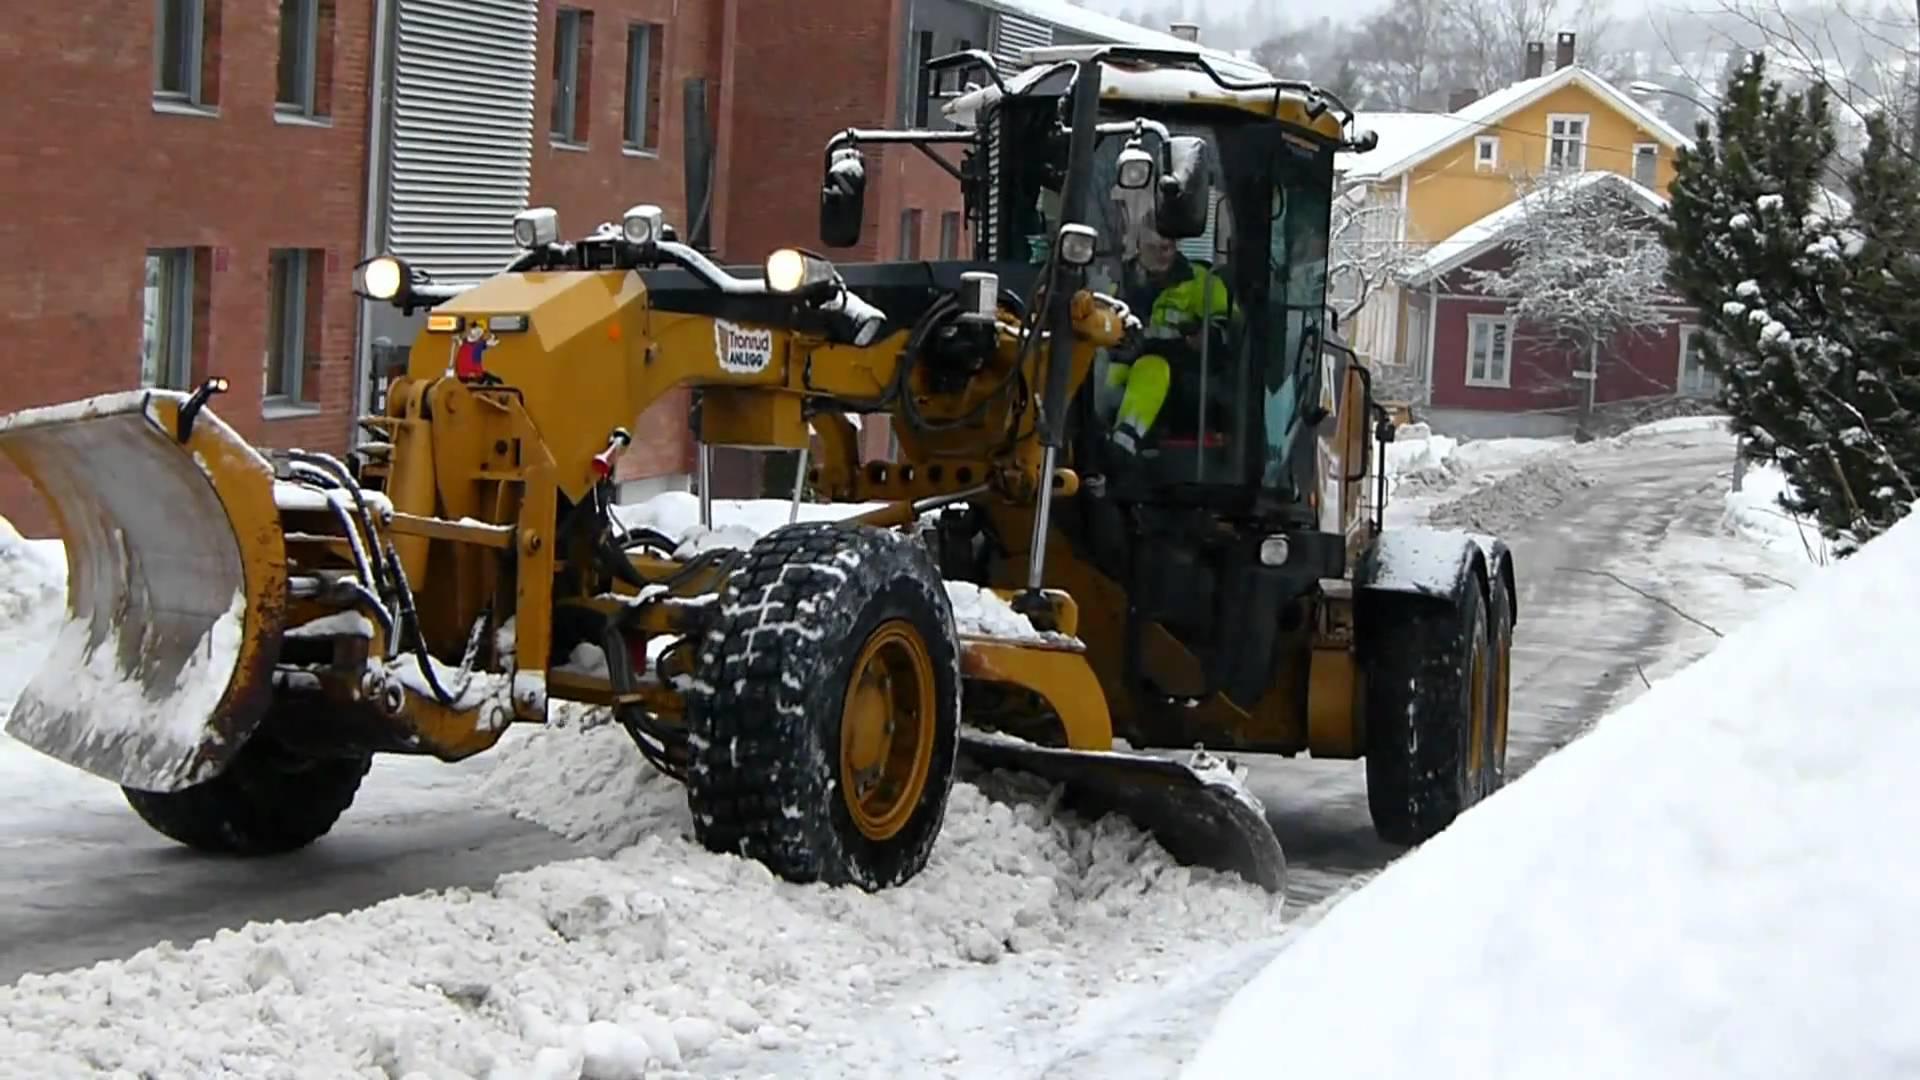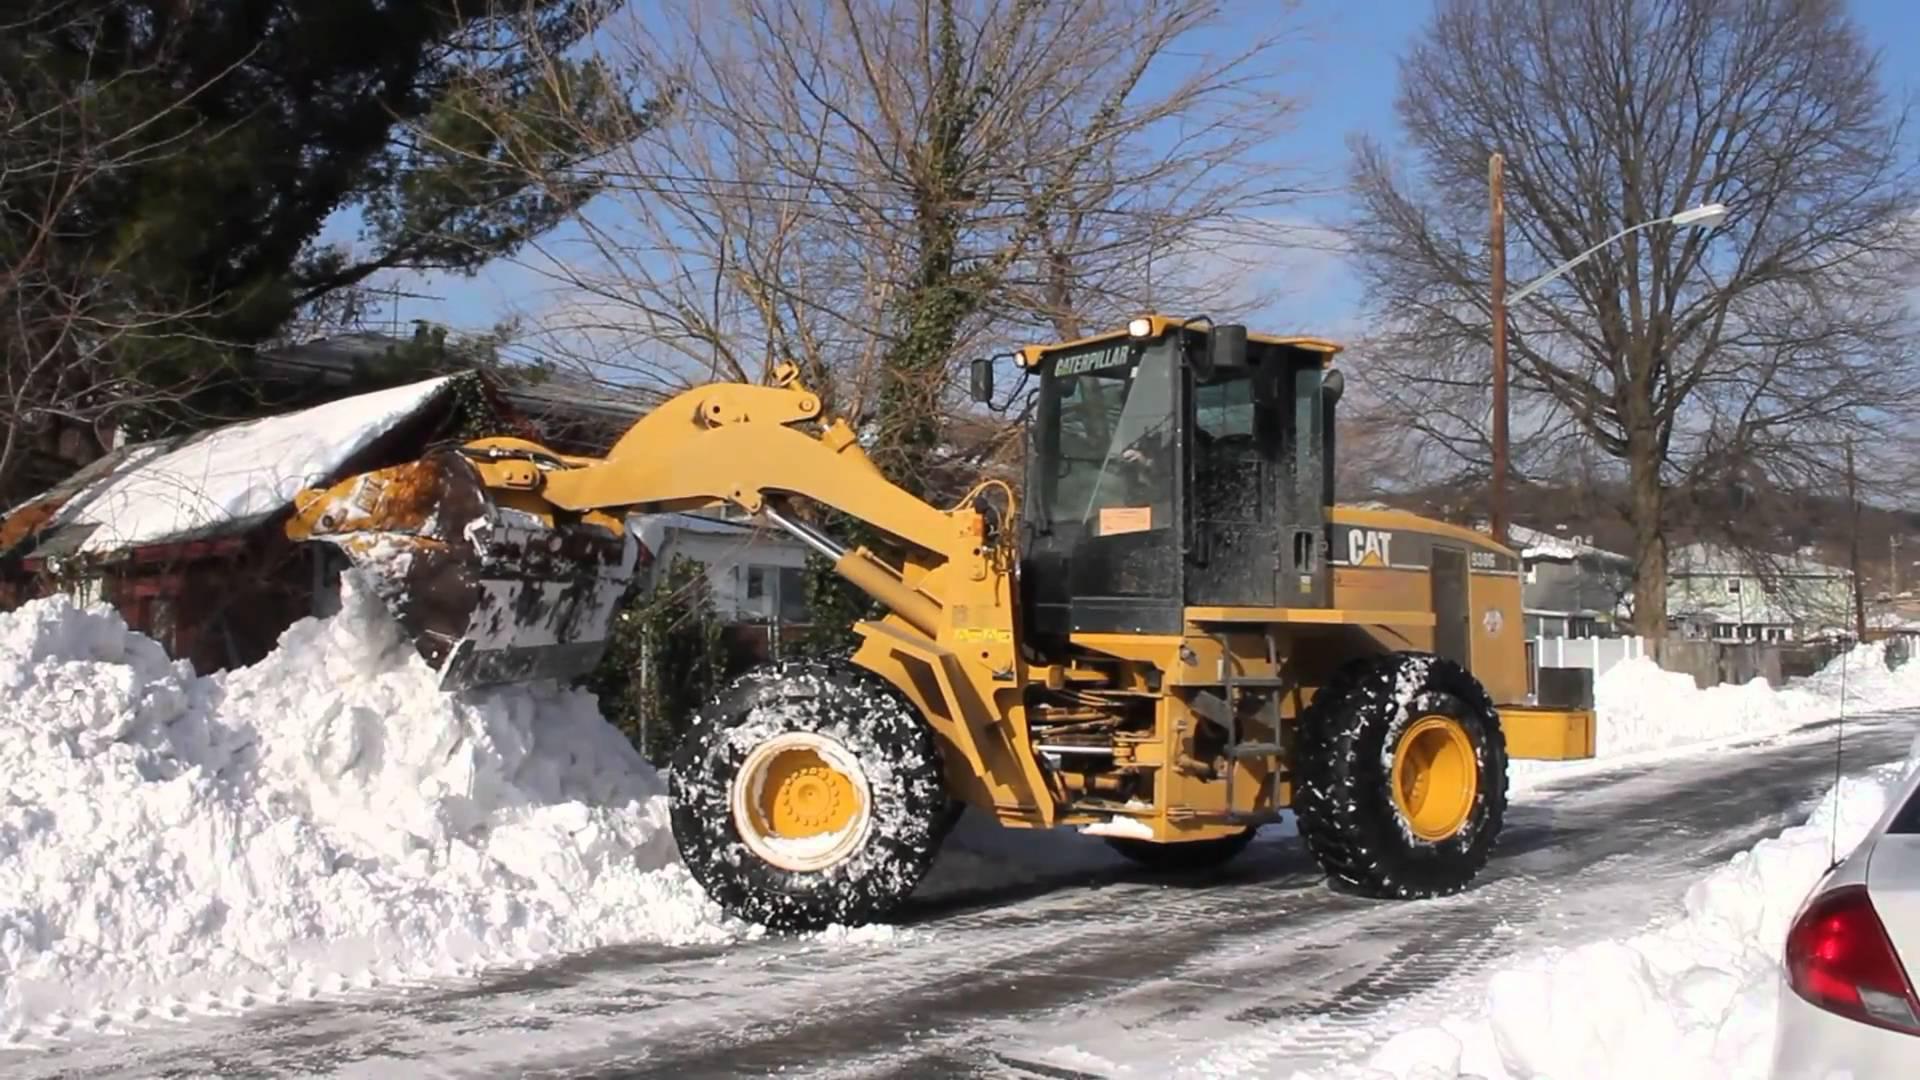The first image is the image on the left, the second image is the image on the right. For the images displayed, is the sentence "one of the trucks is red" factually correct? Answer yes or no. No. 